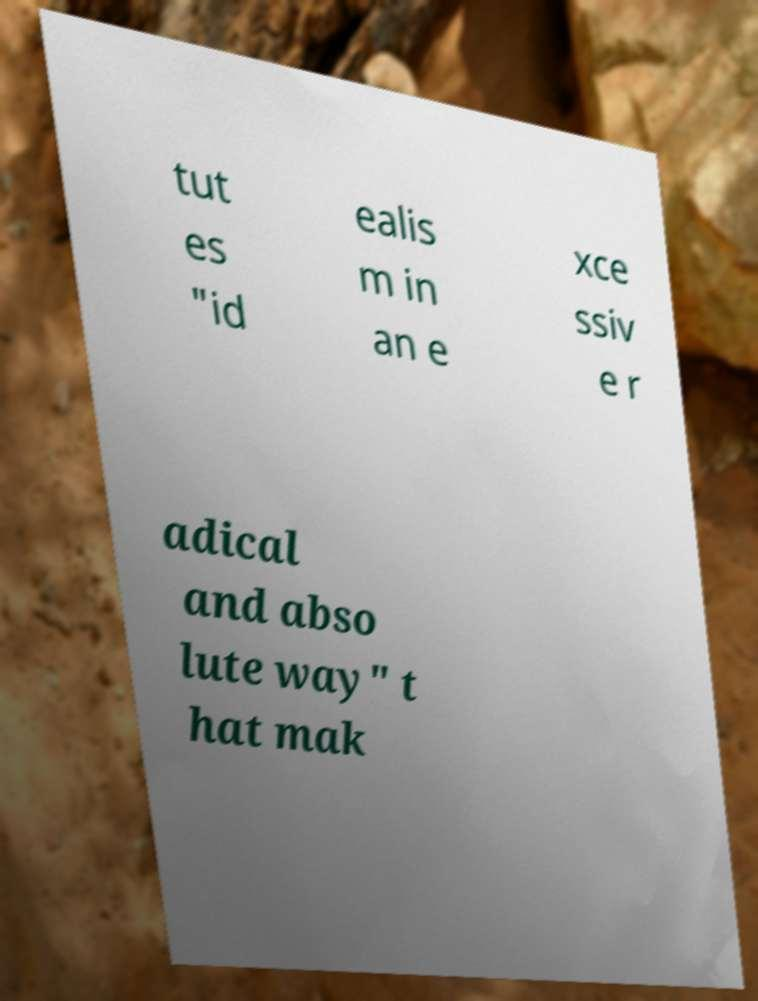Please read and relay the text visible in this image. What does it say? tut es "id ealis m in an e xce ssiv e r adical and abso lute way" t hat mak 